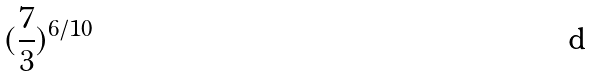<formula> <loc_0><loc_0><loc_500><loc_500>( \frac { 7 } { 3 } ) ^ { 6 / 1 0 }</formula> 